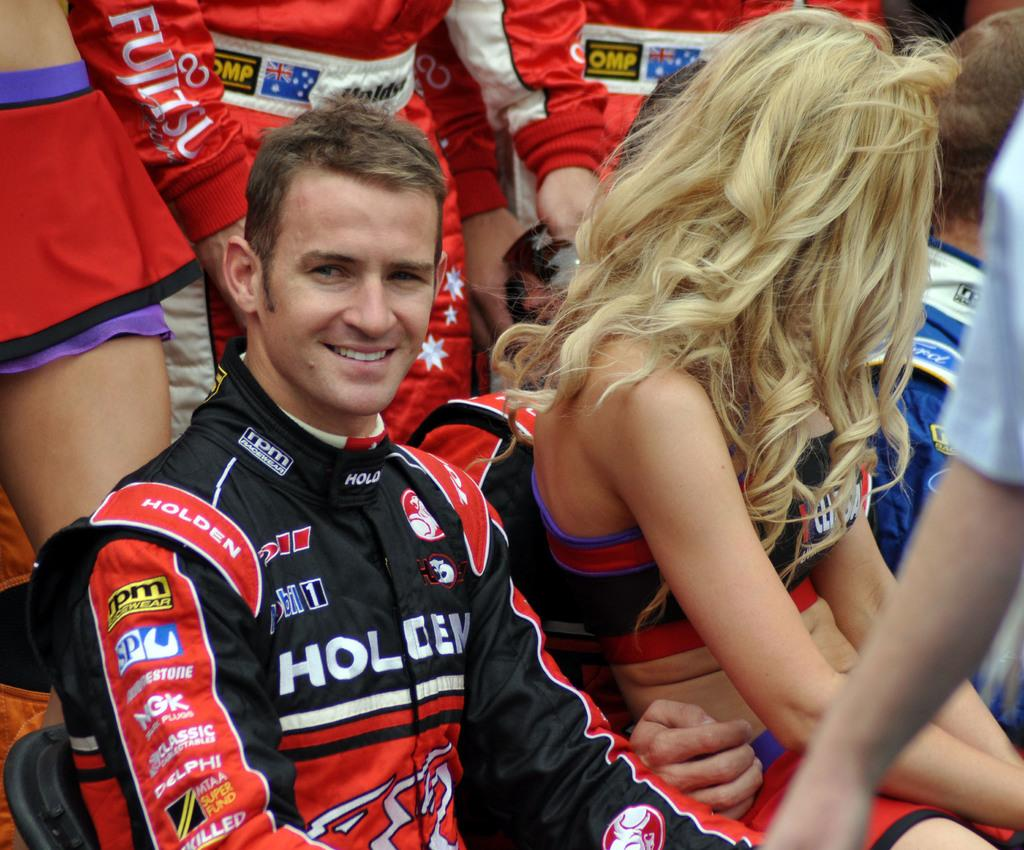<image>
Describe the image concisely. A race car driver with ads on his uniform such as Mobil ! and Holdem 